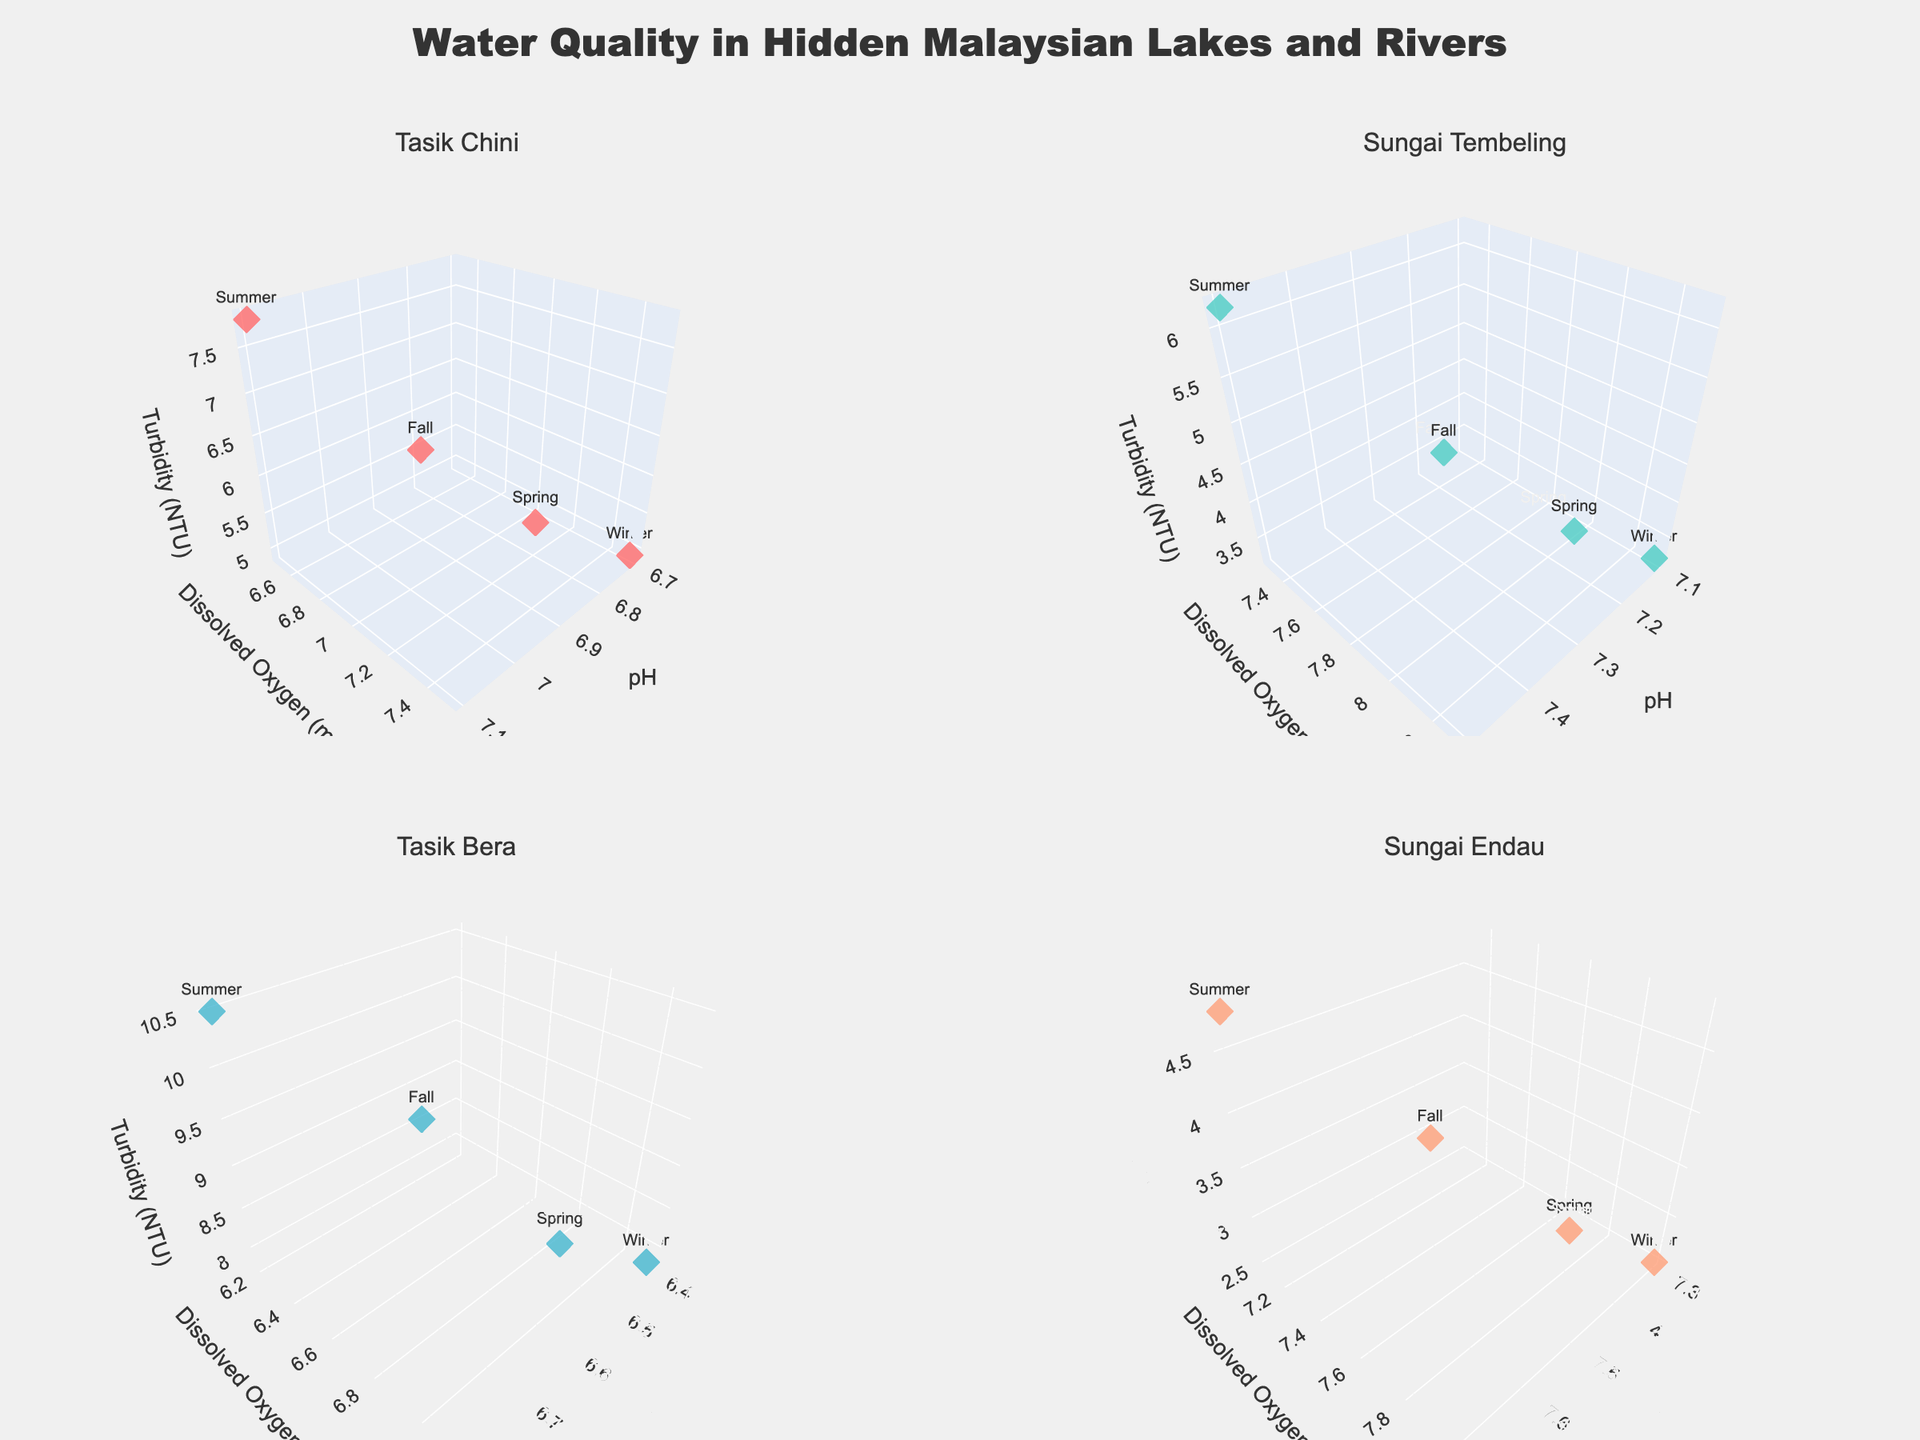What's the title of the figure? The title is usually displayed at the top of the figure. In this case, it's clearly indicated at the top center.
Answer: Water Quality in Hidden Malaysian Lakes and Rivers Which location has the highest turbidity during the Summer? Look at the subplot for each location (Tasik Chini, Sungai Tembeling, Tasik Bera, Sungai Endau), and identify the data point labeled 'Summer'. Compare their turbidity values. Tasik Bera shows the highest turbidity (10.5 NTU) in the Summer.
Answer: Tasik Bera In which season does Sungai Endau have the highest dissolved oxygen level? In the subplot for Sungai Endau, check the dissolved oxygen (y-axis) values for each season. The highest value is during the Winter with 8.0 mg/L of dissolved oxygen.
Answer: Winter How does the pH range in Tasik Chini vary across different seasons? Look at the pH (x-axis) values in the subplot for Tasik Chini and compare the values across different seasons. The pH ranges from 6.7 (Winter) to 7.1 (Summer).
Answer: 6.7 to 7.1 Which location has the least variation in turbidity across seasons? Observe the spread of turbidity (z-axis) values in each subplot. Sungai Endau has the most consistent turbidity values, ranging narrowly from 2.5 NTU to 4.8 NTU.
Answer: Sungai Endau What is the pH value of Sungai Tembeling during the Fall? In the subplot for Sungai Tembeling, find the data point labeled 'Fall' and check its pH (x-axis) value. It corresponds to a pH of 7.3.
Answer: 7.3 Compare the dissolved oxygen levels between Spring and Winter in Tasik Bera. Which season has a higher level? Look at the dissolved oxygen (y-axis) values for Spring and Winter in the subplot for Tasik Bera. Spring has 6.9 mg/L while Winter has 7.1 mg/L, making Winter higher.
Answer: Winter What is the average pH value across all seasons in Sungai Endau? Check the pH (x-axis) values for all seasons in the Sungai Endau subplot: 7.4, 7.7, 7.5, and 7.3. Calculate the average: (7.4 + 7.7 + 7.5 + 7.3) / 4 = 7.475.
Answer: 7.475 Which season shows the highest turbidity recorded in Tasik Chini? In the subplot for Tasik Chini, find the highest turbidity (z-axis) value and check the corresponding season. It’s Summer with a turbidity of 7.8 NTU.
Answer: Summer 